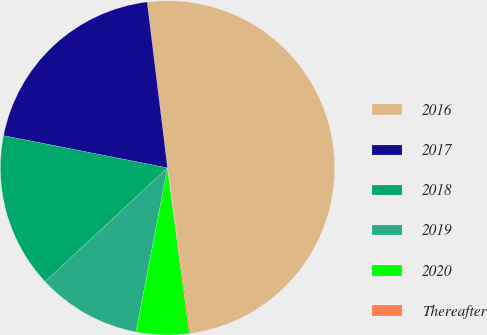Convert chart to OTSL. <chart><loc_0><loc_0><loc_500><loc_500><pie_chart><fcel>2016<fcel>2017<fcel>2018<fcel>2019<fcel>2020<fcel>Thereafter<nl><fcel>49.72%<fcel>19.97%<fcel>15.01%<fcel>10.06%<fcel>5.1%<fcel>0.14%<nl></chart> 